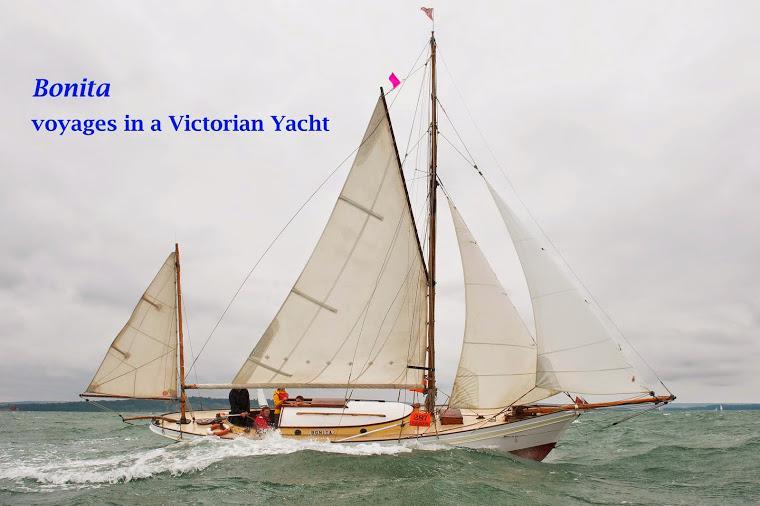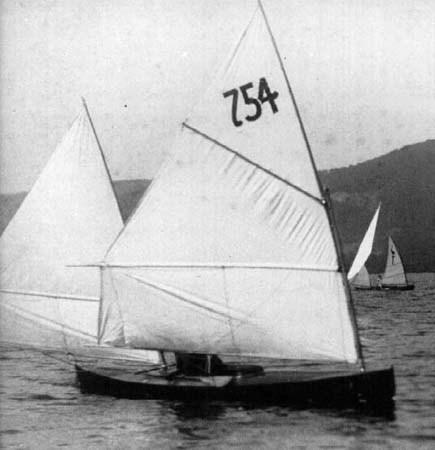The first image is the image on the left, the second image is the image on the right. Assess this claim about the two images: "In the image to the left, the boat has more than four sails unfurled.". Correct or not? Answer yes or no. No. The first image is the image on the left, the second image is the image on the right. For the images displayed, is the sentence "The left image shows a sailboat with a small triangle sail on the left and a nearly flat horizon and a non-blue sky." factually correct? Answer yes or no. Yes. 